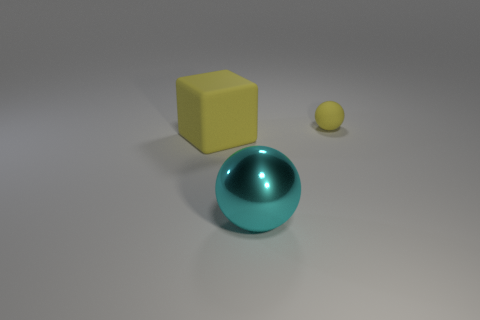There is a cyan object; does it have the same shape as the yellow thing behind the big yellow cube?
Ensure brevity in your answer.  Yes. What is the material of the yellow thing left of the ball that is behind the big sphere?
Offer a very short reply. Rubber. Is the number of tiny spheres in front of the big shiny ball the same as the number of yellow cubes?
Ensure brevity in your answer.  No. Is there any other thing that has the same material as the cyan ball?
Provide a succinct answer. No. There is a object on the right side of the large ball; does it have the same color as the large object right of the yellow cube?
Ensure brevity in your answer.  No. What number of spheres are both behind the large rubber cube and in front of the small matte ball?
Ensure brevity in your answer.  0. What number of other things are the same shape as the cyan object?
Your response must be concise. 1. Are there more big yellow matte things that are behind the small object than yellow cubes?
Your response must be concise. No. What color is the matte object in front of the rubber ball?
Provide a succinct answer. Yellow. There is a rubber sphere that is the same color as the big rubber block; what size is it?
Give a very brief answer. Small. 